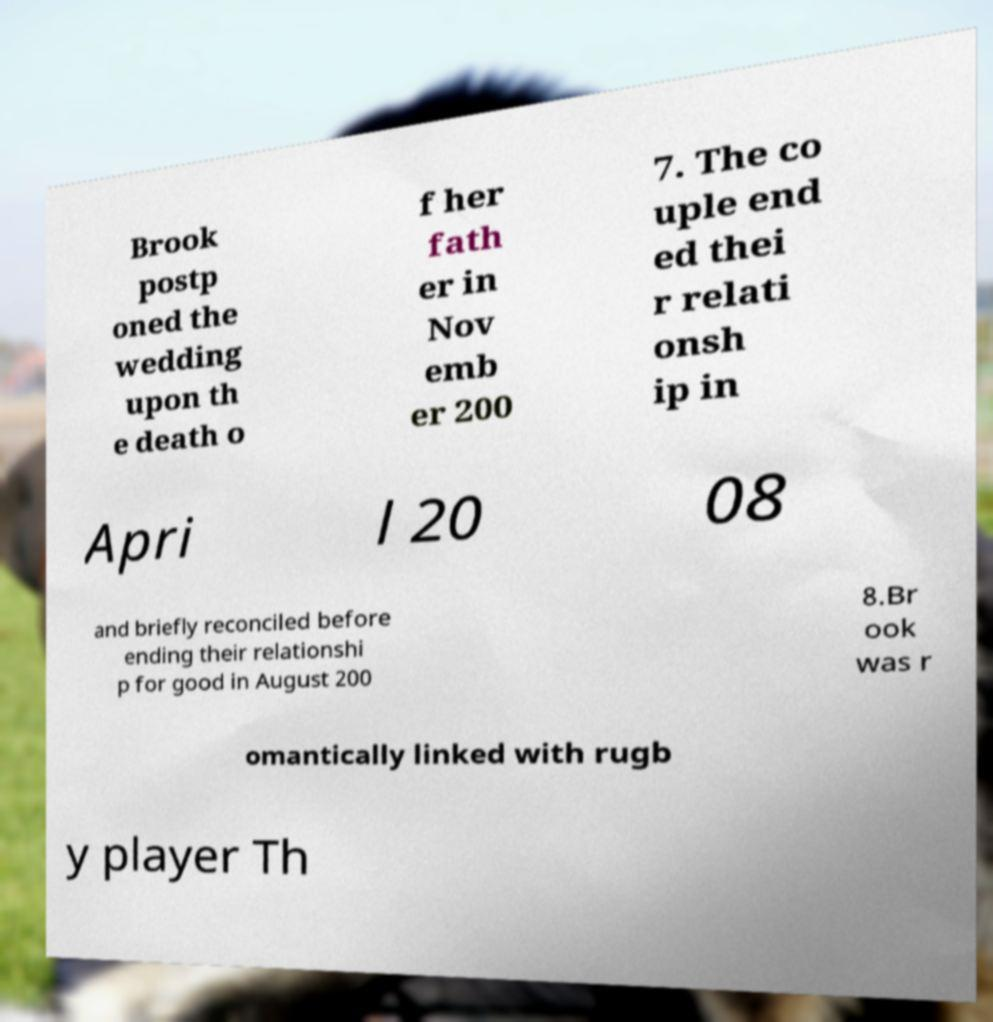Can you read and provide the text displayed in the image?This photo seems to have some interesting text. Can you extract and type it out for me? Brook postp oned the wedding upon th e death o f her fath er in Nov emb er 200 7. The co uple end ed thei r relati onsh ip in Apri l 20 08 and briefly reconciled before ending their relationshi p for good in August 200 8.Br ook was r omantically linked with rugb y player Th 